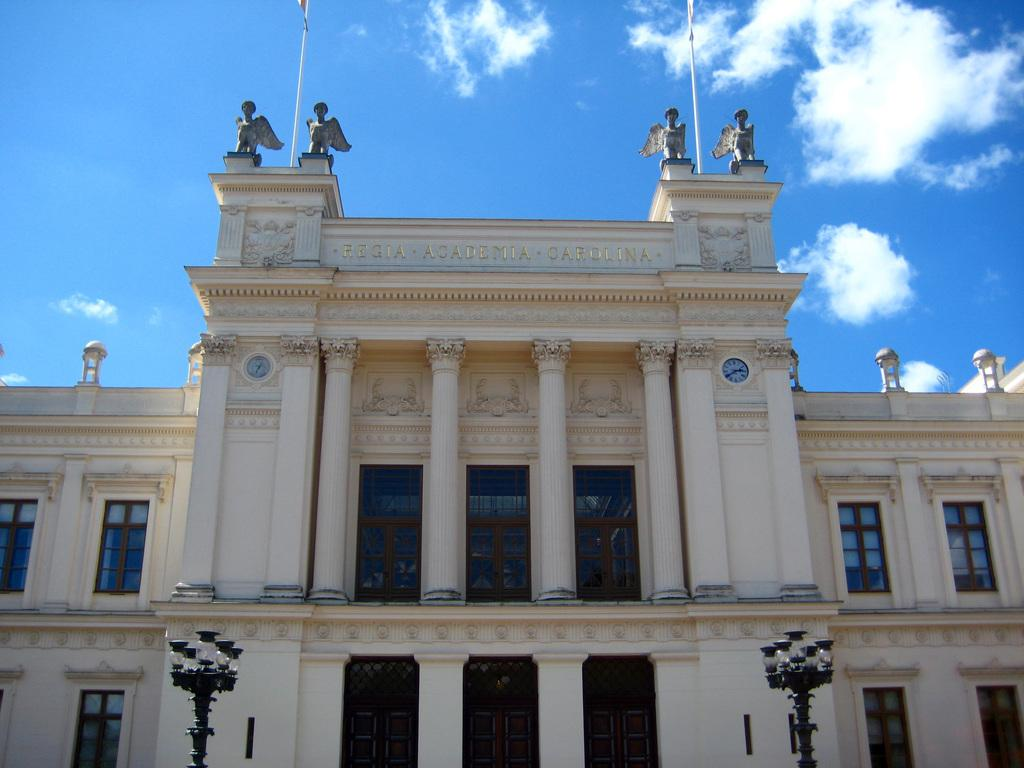What type of structure is visible in the image? There is a building in the image. What architectural features can be seen on the building? There are light poles, windows, pillars, clocks, and flag poles visible on the building. Are there any decorative elements present on the building? Yes, there are statues present on the building. What can be seen in the background of the image? The sky with clouds is visible in the background of the image. What type of bell can be heard ringing in the image? There is no bell present in the image, and therefore no sound can be heard. Can you tell me how many needles are used to create the statues in the image? There is no information about the creation process of the statues in the image, and therefore we cannot determine the number of needles used. 